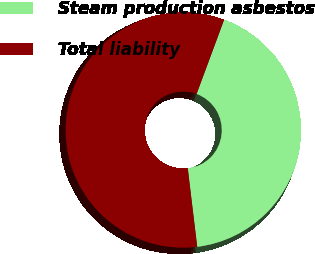Convert chart. <chart><loc_0><loc_0><loc_500><loc_500><pie_chart><fcel>Steam production asbestos<fcel>Total liability<nl><fcel>42.44%<fcel>57.56%<nl></chart> 